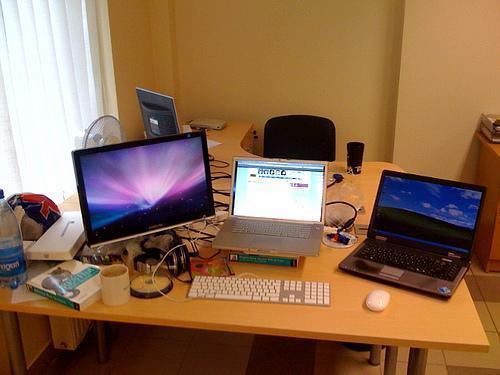What is the white rounded object on the right?
Answer the question by selecting the correct answer among the 4 following choices.
Options: Mouse, router, case, soap. Mouse. 